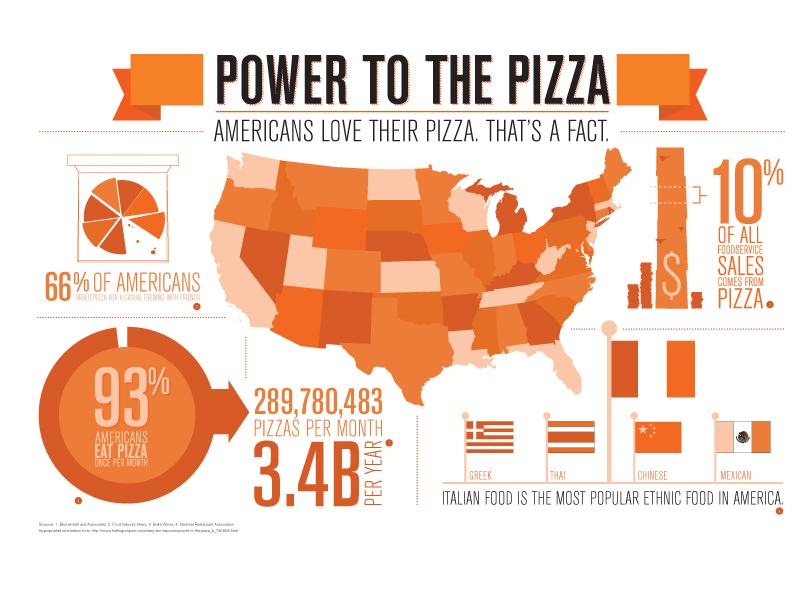Indicate a few pertinent items in this graphic. A recent survey found that 93% of Americans consume pizza at least once a month. According to recent statistics, pizza accounts for approximately 10% of total food service sales in the United States. It is estimated that approximately 289,780,483 pizzas are consumed by Americans on a monthly basis. According to a recent survey, only 7% of Americans do not consume pizza at least once per month. In America, over 90% of food service sales do not come from pizza. 